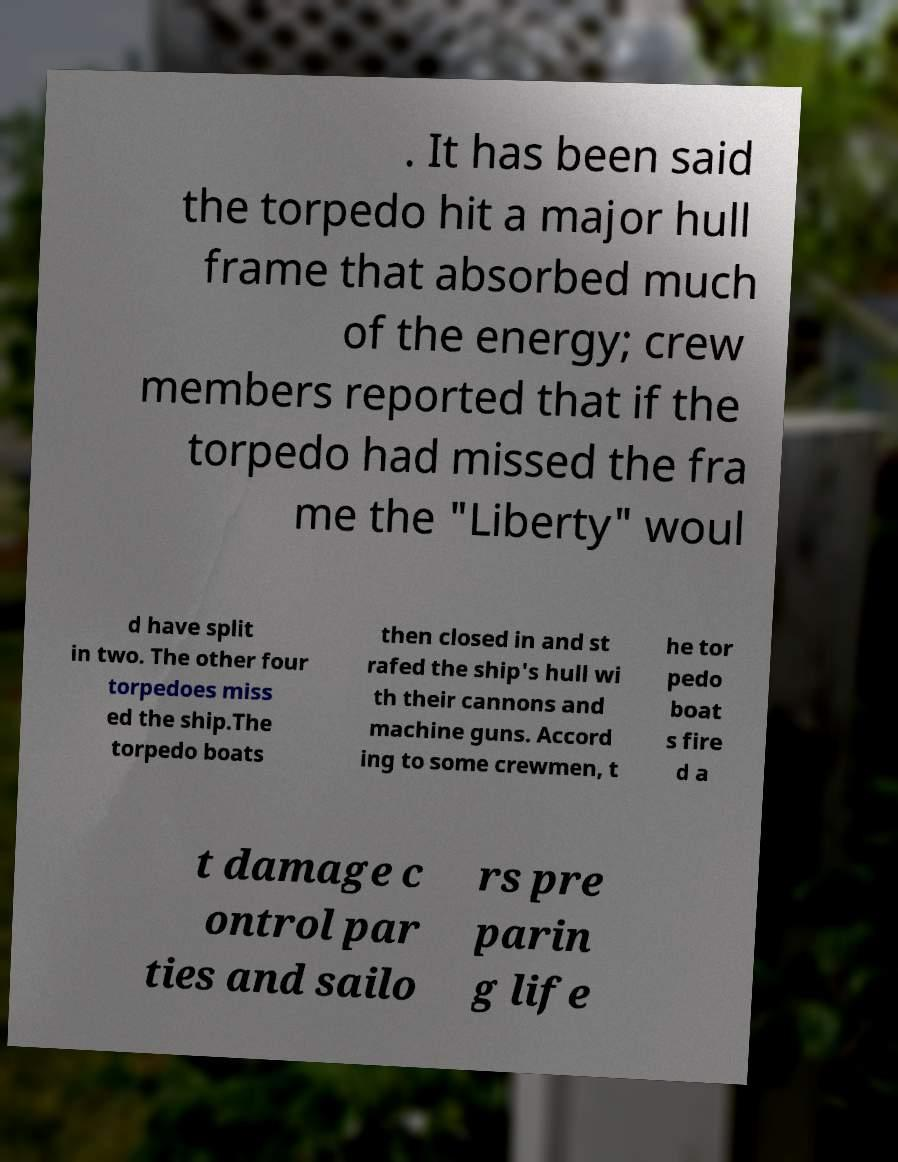Can you read and provide the text displayed in the image?This photo seems to have some interesting text. Can you extract and type it out for me? . It has been said the torpedo hit a major hull frame that absorbed much of the energy; crew members reported that if the torpedo had missed the fra me the "Liberty" woul d have split in two. The other four torpedoes miss ed the ship.The torpedo boats then closed in and st rafed the ship's hull wi th their cannons and machine guns. Accord ing to some crewmen, t he tor pedo boat s fire d a t damage c ontrol par ties and sailo rs pre parin g life 